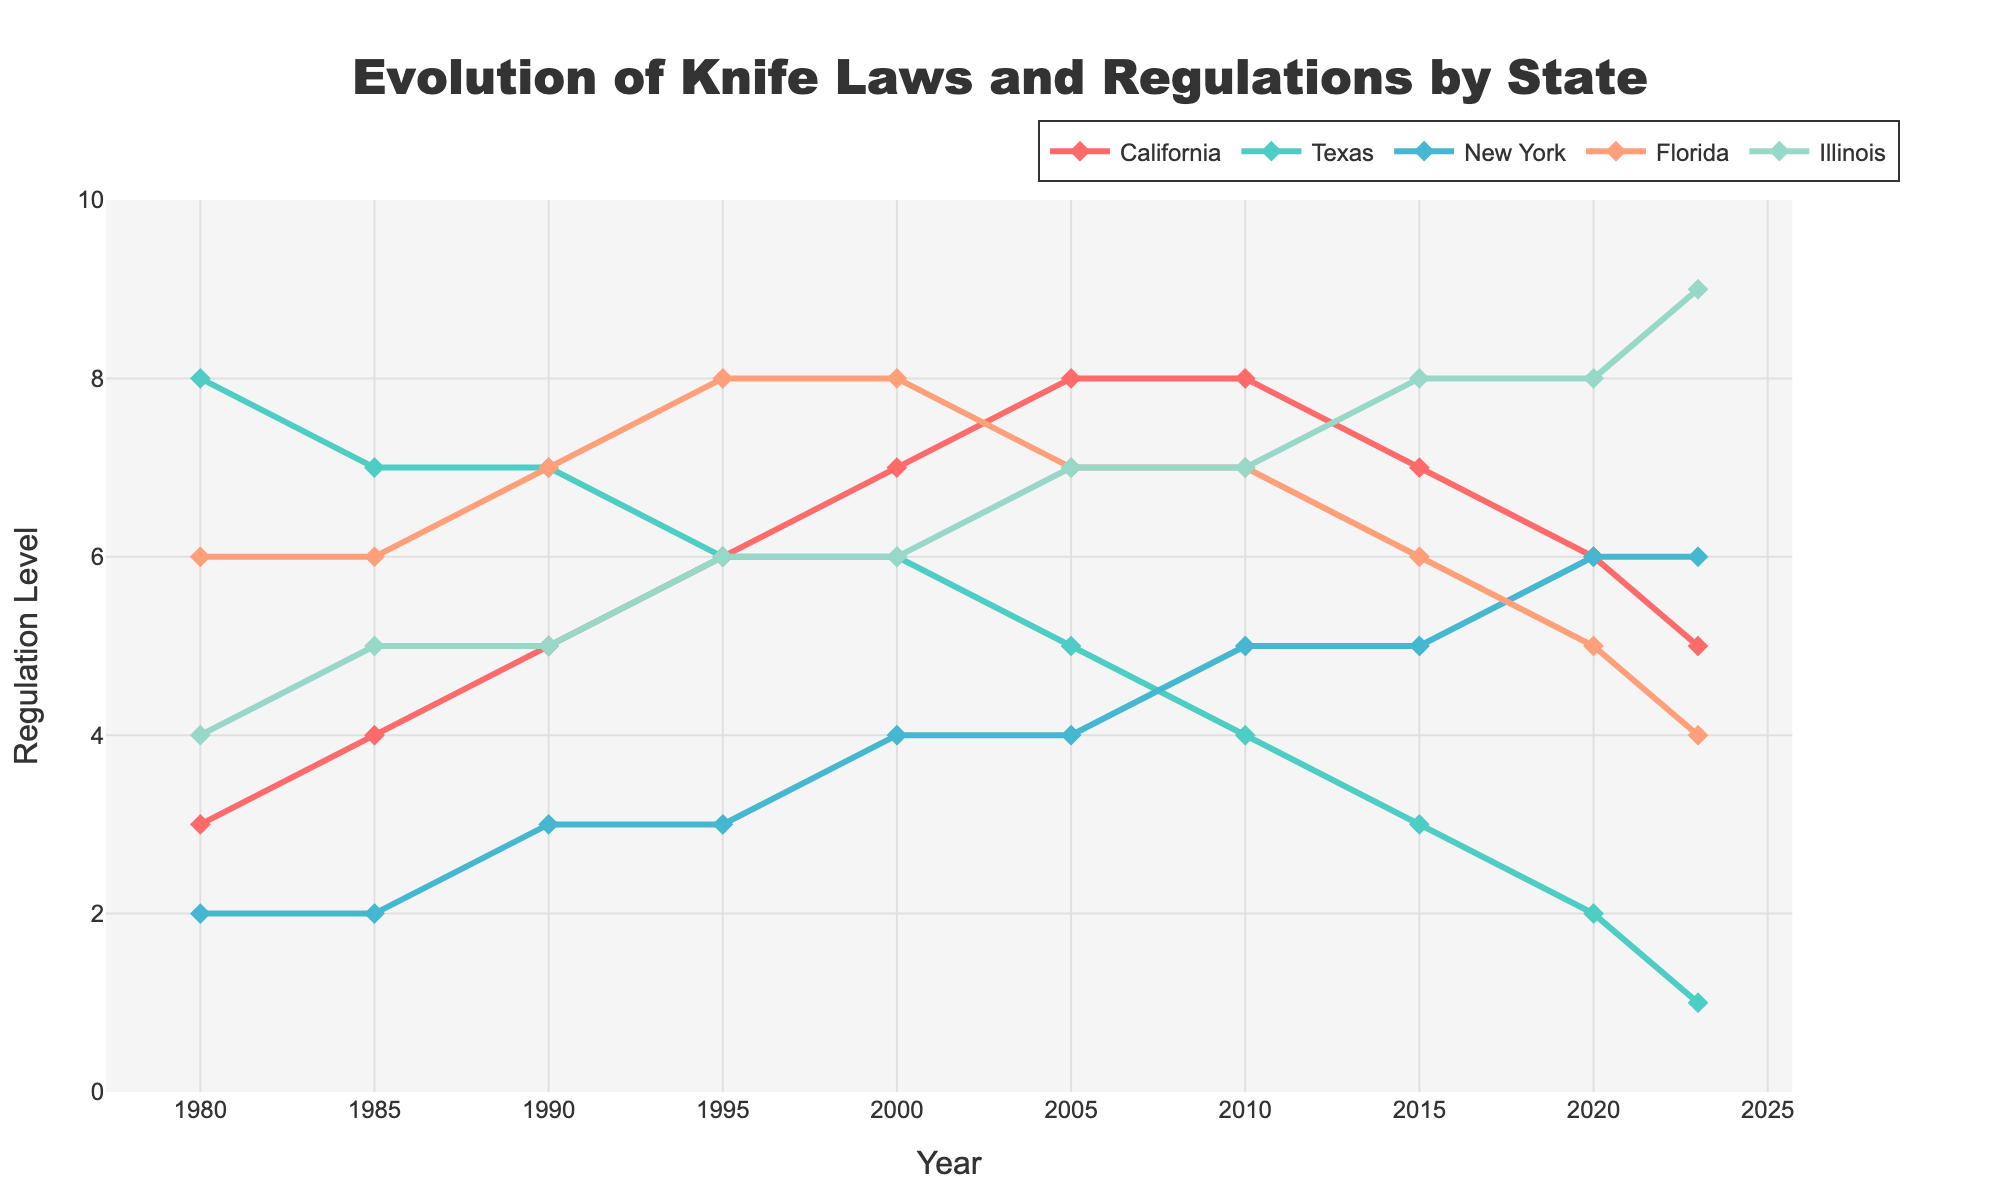What state had the highest regulation level in 2015? Look at the lines on the graph for each state in the year 2015. The state with the highest point will be the one with the highest regulation level. The yellow/orange line (Illinois) reaches up to 8 in 2015.
Answer: Illinois How did California's regulation level change from 1980 to 2023? Follow the red line representing California from 1980 to 2023 and observe the change in values. California starts at 3 in 1980 and ends at 5 in 2023, increasing initially and then decreasing in recent years.
Answer: From 3 to 5 Which state showed the most consistent regulations from 1980 to 2023? Consistent regulation levels would appear as a line with the least fluctuation. The blue line (New York) shows the least fluctuation overall.
Answer: New York What's the average regulation level for Florida across all years? Sum the regulation levels for Florida across all years (6 + 6 + 7 + 8 + 8 + 7 + 7 + 6 + 5 + 4) and then divide by the number of years (10). This gives the average.
Answer: 6.4 Between 2000 and 2023, how much did Illinois' regulation level increase or decrease? Locate Illinois' values in 2000 (6) and in 2023 (9), then subtract to find the difference. Illinois' regulation level increased from 6 to 9, so the increase is 9 - 6 = 3.
Answer: Increased by 3 Which year did Texas have the highest regulation level and what was it? Follow the green line representing Texas, and identify the peak value. The peak value for Texas is 8 in 1980.
Answer: 1980, at 8 Compare the regulation levels of California and New York in 2020. Which state had a higher regulation level? Look at the line for California and New York in the year 2020. California (red line) is at 6, while New York (blue line) is also at 6. Both states had the same regulation level.
Answer: Same What is the difference between the regulation levels of Florida and Texas in 2010? Identify the levels for both Florida and Texas in 2010. Florida's regulation level is 7, and Texas' is 4. So, the difference is 7 - 4 = 3.
Answer: 3 How did the regulation levels for New York and Illinois compare in 1985? Check the graph in 1985 for New York and Illinois. New York's regulation level was 2, while Illinois' was 5. Illinois had a higher regulation level than New York.
Answer: Illinois higher When did California's regulation level peak, and what was the level? Follow the red line for California to identify the highest point. California's highest point was in 2005, at a regulation level of 8.
Answer: 2005, at 8 